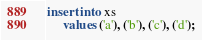<code> <loc_0><loc_0><loc_500><loc_500><_SQL_>insert into xs
     values ('a'), ('b'), ('c'), ('d');</code> 